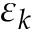<formula> <loc_0><loc_0><loc_500><loc_500>\varepsilon _ { k }</formula> 